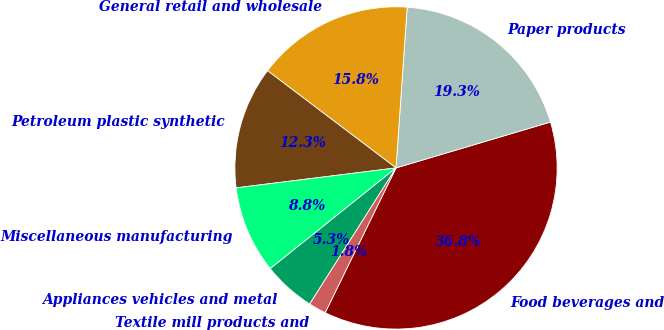Convert chart to OTSL. <chart><loc_0><loc_0><loc_500><loc_500><pie_chart><fcel>Food beverages and<fcel>Paper products<fcel>General retail and wholesale<fcel>Petroleum plastic synthetic<fcel>Miscellaneous manufacturing<fcel>Appliances vehicles and metal<fcel>Textile mill products and<nl><fcel>36.84%<fcel>19.3%<fcel>15.79%<fcel>12.28%<fcel>8.77%<fcel>5.26%<fcel>1.75%<nl></chart> 